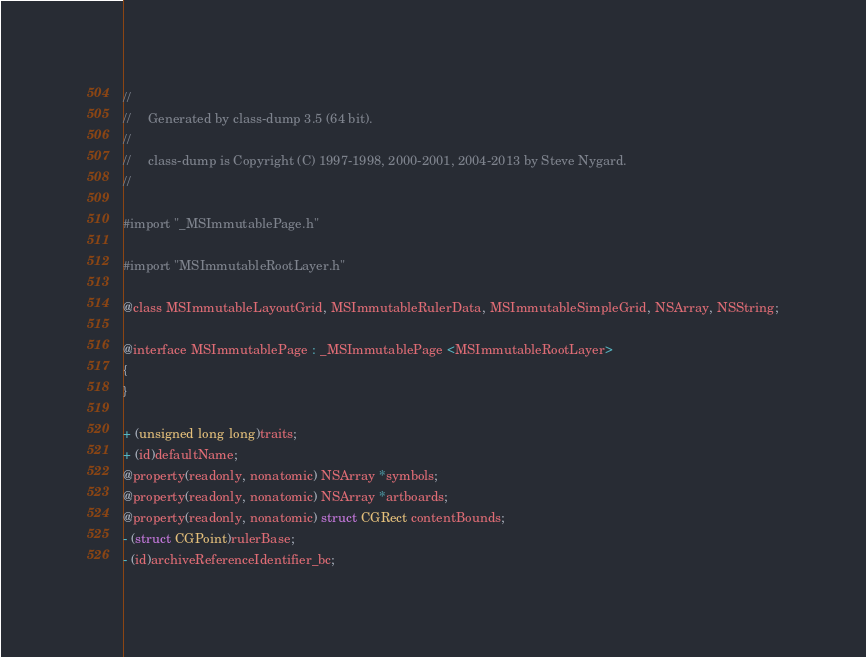<code> <loc_0><loc_0><loc_500><loc_500><_C_>//
//     Generated by class-dump 3.5 (64 bit).
//
//     class-dump is Copyright (C) 1997-1998, 2000-2001, 2004-2013 by Steve Nygard.
//

#import "_MSImmutablePage.h"

#import "MSImmutableRootLayer.h"

@class MSImmutableLayoutGrid, MSImmutableRulerData, MSImmutableSimpleGrid, NSArray, NSString;

@interface MSImmutablePage : _MSImmutablePage <MSImmutableRootLayer>
{
}

+ (unsigned long long)traits;
+ (id)defaultName;
@property(readonly, nonatomic) NSArray *symbols;
@property(readonly, nonatomic) NSArray *artboards;
@property(readonly, nonatomic) struct CGRect contentBounds;
- (struct CGPoint)rulerBase;
- (id)archiveReferenceIdentifier_bc;</code> 